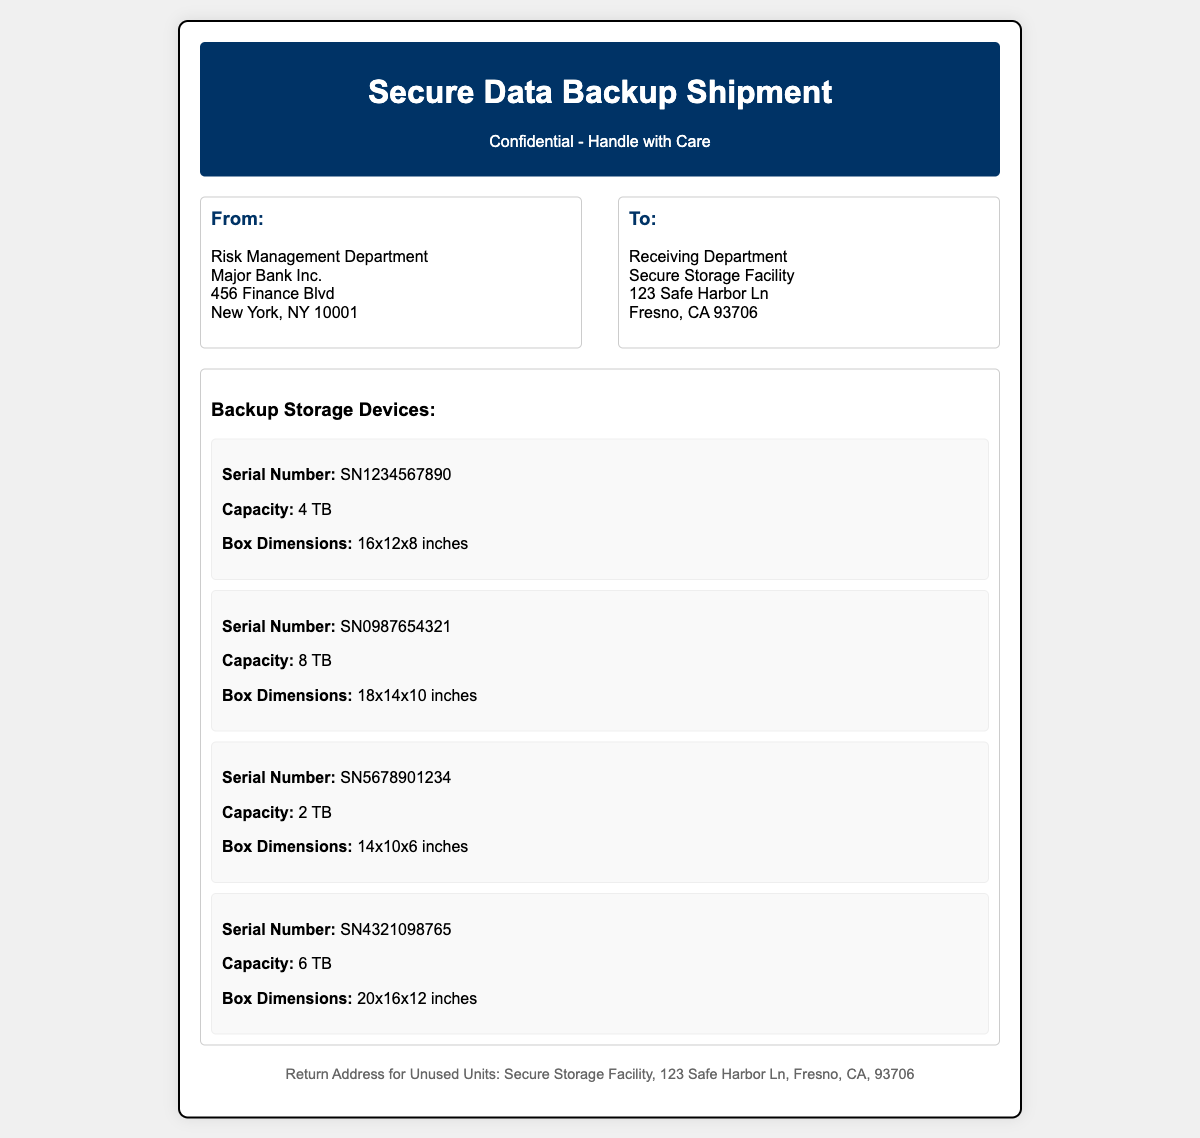what is the serial number of the first device? The serial number of the first device is listed in the devices section of the document.
Answer: SN1234567890 what is the capacity of the second device? The capacity of the second device is provided in the details of that device.
Answer: 8 TB how many devices are listed in total? The total number of devices can be counted from the devices section.
Answer: 4 what are the box dimensions of the third device? The box dimensions are specifically stated for each device in the document.
Answer: 14x10x6 inches what is the return address for unused units? The return address for unused units is mentioned at the bottom of the document.
Answer: Secure Storage Facility, 123 Safe Harbor Ln, Fresno, CA, 93706 which device has the highest capacity? To find the device with the highest capacity, compare the capacity of each device listed.
Answer: 8 TB what is the background color of the header? The background color of the header can be determined from the header section's style.
Answer: Dark blue how many inches are the box dimensions of the fourth device? The box dimensions of the fourth device are specified in the devices section.
Answer: 20x16x12 inches 